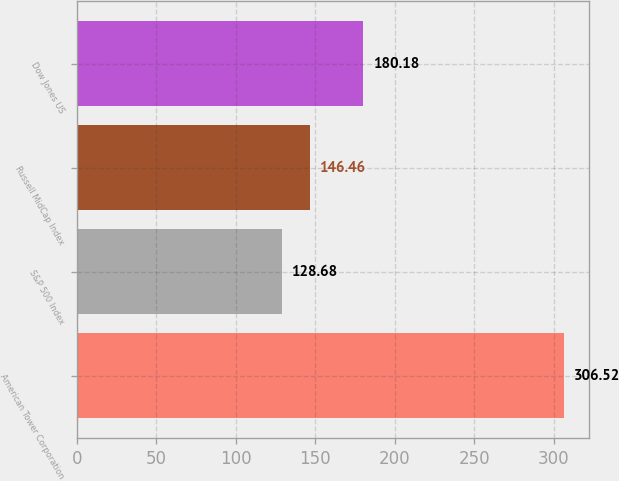Convert chart. <chart><loc_0><loc_0><loc_500><loc_500><bar_chart><fcel>American Tower Corporation<fcel>S&P 500 Index<fcel>Russell MidCap Index<fcel>Dow Jones US<nl><fcel>306.52<fcel>128.68<fcel>146.46<fcel>180.18<nl></chart> 